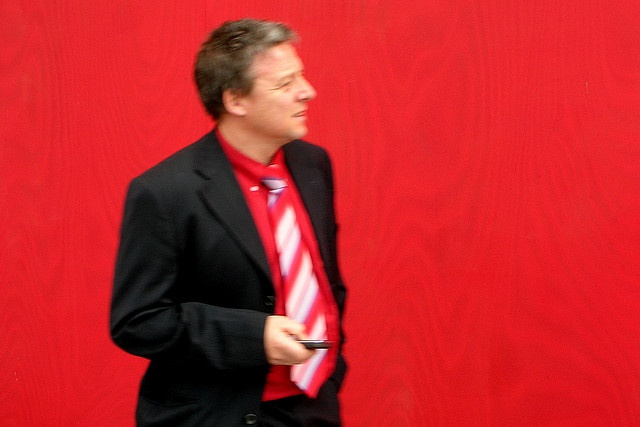Describe the objects in this image and their specific colors. I can see people in red, black, maroon, and salmon tones, tie in red, pink, lightpink, and salmon tones, remote in red, maroon, white, gray, and black tones, and cell phone in red, maroon, gray, and black tones in this image. 